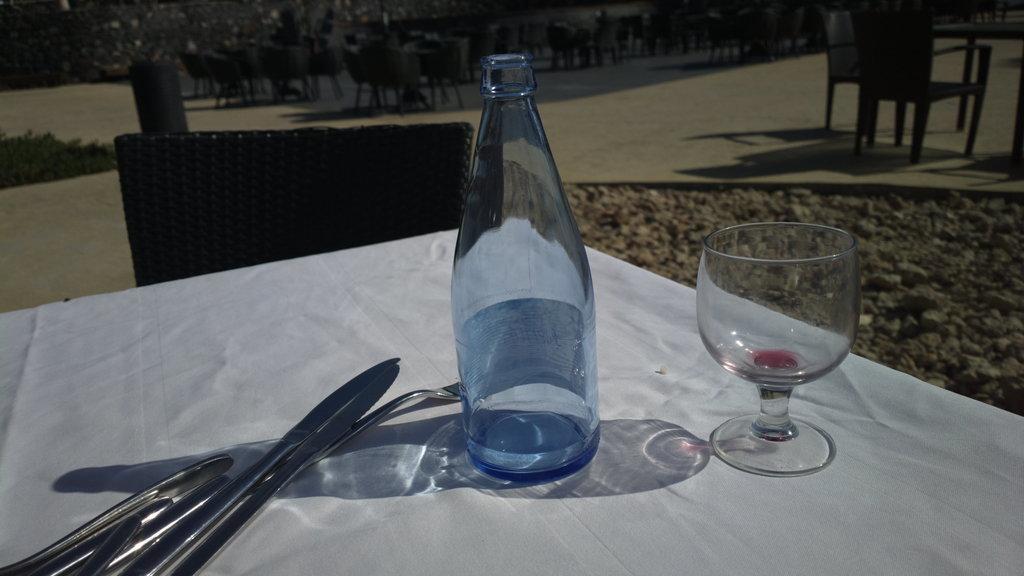Describe this image in one or two sentences. There is a table. On the table there is a white sheet, knives, forks, bottle and glass. There are chairs. In the background there are many chairs and trees. 